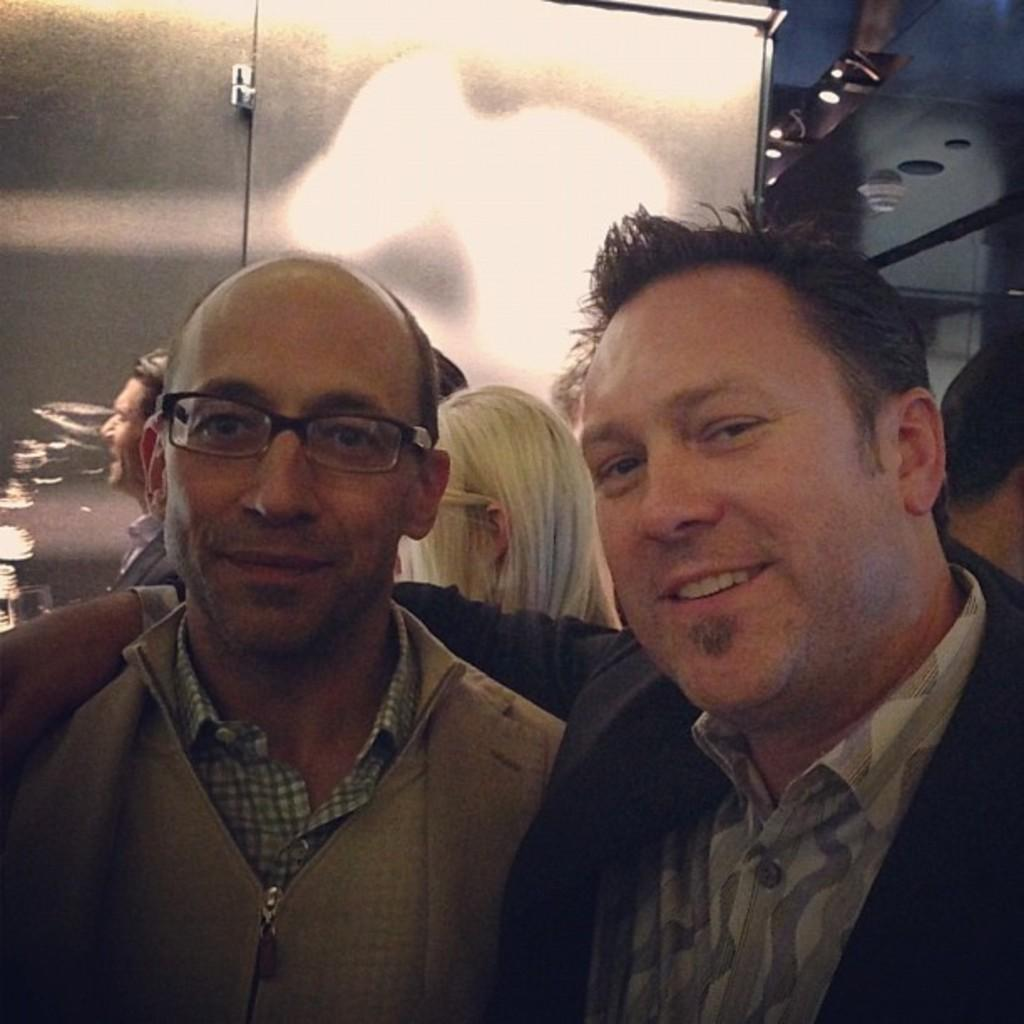How many people are present in the image? There are two people in the image. What is the facial expression of the people in the image? Both people are smiling. Can you describe one of the people in the image? One person is wearing spectacles. What can be seen in the background of the image? There is a group of people, a roof, lights, and some objects visible in the background. What is the price of the insurance policy being discussed in the image? There is no mention of insurance or any discussion about it in the image. 